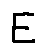<formula> <loc_0><loc_0><loc_500><loc_500>E</formula> 